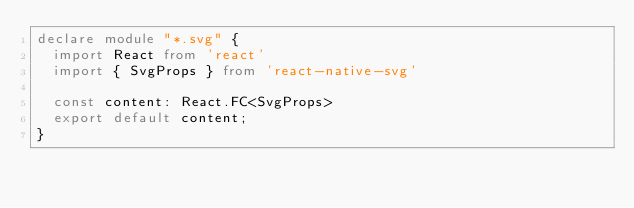Convert code to text. <code><loc_0><loc_0><loc_500><loc_500><_TypeScript_>declare module "*.svg" {
  import React from 'react'
  import { SvgProps } from 'react-native-svg'

  const content: React.FC<SvgProps>
  export default content;
}</code> 